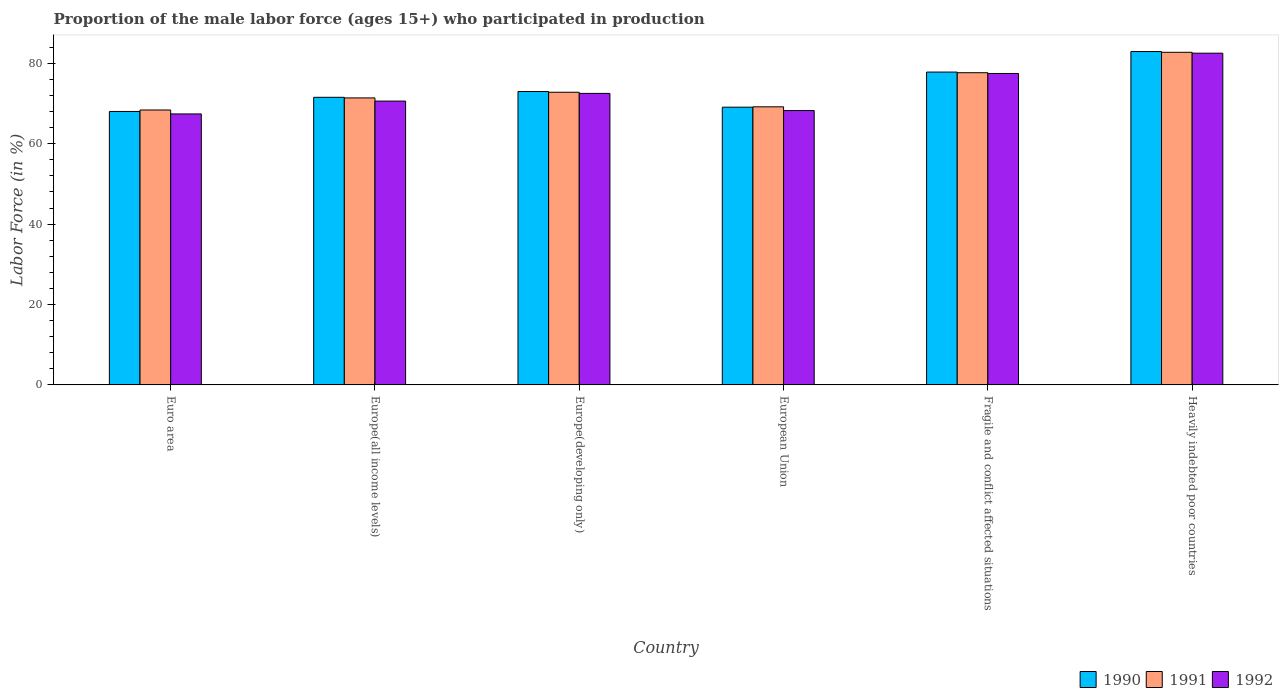How many different coloured bars are there?
Your answer should be compact. 3. How many groups of bars are there?
Ensure brevity in your answer.  6. How many bars are there on the 4th tick from the left?
Ensure brevity in your answer.  3. In how many cases, is the number of bars for a given country not equal to the number of legend labels?
Provide a succinct answer. 0. What is the proportion of the male labor force who participated in production in 1991 in Europe(all income levels)?
Give a very brief answer. 71.41. Across all countries, what is the maximum proportion of the male labor force who participated in production in 1990?
Give a very brief answer. 82.95. Across all countries, what is the minimum proportion of the male labor force who participated in production in 1990?
Provide a succinct answer. 68.04. In which country was the proportion of the male labor force who participated in production in 1990 maximum?
Ensure brevity in your answer.  Heavily indebted poor countries. In which country was the proportion of the male labor force who participated in production in 1992 minimum?
Your response must be concise. Euro area. What is the total proportion of the male labor force who participated in production in 1992 in the graph?
Provide a succinct answer. 438.87. What is the difference between the proportion of the male labor force who participated in production in 1992 in Europe(developing only) and that in Fragile and conflict affected situations?
Provide a short and direct response. -4.96. What is the difference between the proportion of the male labor force who participated in production in 1992 in Euro area and the proportion of the male labor force who participated in production in 1990 in Europe(all income levels)?
Your response must be concise. -4.14. What is the average proportion of the male labor force who participated in production in 1992 per country?
Provide a short and direct response. 73.14. What is the difference between the proportion of the male labor force who participated in production of/in 1991 and proportion of the male labor force who participated in production of/in 1992 in European Union?
Your response must be concise. 0.93. In how many countries, is the proportion of the male labor force who participated in production in 1992 greater than 52 %?
Ensure brevity in your answer.  6. What is the ratio of the proportion of the male labor force who participated in production in 1990 in Euro area to that in Europe(developing only)?
Keep it short and to the point. 0.93. Is the difference between the proportion of the male labor force who participated in production in 1991 in Europe(all income levels) and Fragile and conflict affected situations greater than the difference between the proportion of the male labor force who participated in production in 1992 in Europe(all income levels) and Fragile and conflict affected situations?
Your response must be concise. Yes. What is the difference between the highest and the second highest proportion of the male labor force who participated in production in 1992?
Make the answer very short. -10. What is the difference between the highest and the lowest proportion of the male labor force who participated in production in 1990?
Provide a succinct answer. 14.91. What does the 3rd bar from the left in Fragile and conflict affected situations represents?
Your answer should be very brief. 1992. Is it the case that in every country, the sum of the proportion of the male labor force who participated in production in 1990 and proportion of the male labor force who participated in production in 1992 is greater than the proportion of the male labor force who participated in production in 1991?
Give a very brief answer. Yes. How many bars are there?
Your answer should be very brief. 18. Are all the bars in the graph horizontal?
Give a very brief answer. No. How many countries are there in the graph?
Your response must be concise. 6. What is the difference between two consecutive major ticks on the Y-axis?
Make the answer very short. 20. Are the values on the major ticks of Y-axis written in scientific E-notation?
Offer a terse response. No. Does the graph contain grids?
Ensure brevity in your answer.  No. How are the legend labels stacked?
Keep it short and to the point. Horizontal. What is the title of the graph?
Provide a short and direct response. Proportion of the male labor force (ages 15+) who participated in production. Does "1984" appear as one of the legend labels in the graph?
Give a very brief answer. No. What is the label or title of the Y-axis?
Provide a succinct answer. Labor Force (in %). What is the Labor Force (in %) in 1990 in Euro area?
Offer a terse response. 68.04. What is the Labor Force (in %) of 1991 in Euro area?
Provide a short and direct response. 68.4. What is the Labor Force (in %) in 1992 in Euro area?
Your answer should be very brief. 67.42. What is the Labor Force (in %) in 1990 in Europe(all income levels)?
Make the answer very short. 71.56. What is the Labor Force (in %) in 1991 in Europe(all income levels)?
Give a very brief answer. 71.41. What is the Labor Force (in %) of 1992 in Europe(all income levels)?
Make the answer very short. 70.62. What is the Labor Force (in %) of 1990 in Europe(developing only)?
Offer a terse response. 73. What is the Labor Force (in %) in 1991 in Europe(developing only)?
Ensure brevity in your answer.  72.82. What is the Labor Force (in %) of 1992 in Europe(developing only)?
Your answer should be very brief. 72.53. What is the Labor Force (in %) in 1990 in European Union?
Make the answer very short. 69.1. What is the Labor Force (in %) of 1991 in European Union?
Offer a terse response. 69.19. What is the Labor Force (in %) of 1992 in European Union?
Ensure brevity in your answer.  68.26. What is the Labor Force (in %) in 1990 in Fragile and conflict affected situations?
Offer a terse response. 77.84. What is the Labor Force (in %) in 1991 in Fragile and conflict affected situations?
Offer a very short reply. 77.68. What is the Labor Force (in %) in 1992 in Fragile and conflict affected situations?
Make the answer very short. 77.49. What is the Labor Force (in %) of 1990 in Heavily indebted poor countries?
Your answer should be very brief. 82.95. What is the Labor Force (in %) in 1991 in Heavily indebted poor countries?
Offer a terse response. 82.76. What is the Labor Force (in %) of 1992 in Heavily indebted poor countries?
Your answer should be compact. 82.54. Across all countries, what is the maximum Labor Force (in %) of 1990?
Your response must be concise. 82.95. Across all countries, what is the maximum Labor Force (in %) of 1991?
Provide a short and direct response. 82.76. Across all countries, what is the maximum Labor Force (in %) of 1992?
Your answer should be compact. 82.54. Across all countries, what is the minimum Labor Force (in %) of 1990?
Provide a short and direct response. 68.04. Across all countries, what is the minimum Labor Force (in %) of 1991?
Your answer should be very brief. 68.4. Across all countries, what is the minimum Labor Force (in %) in 1992?
Ensure brevity in your answer.  67.42. What is the total Labor Force (in %) in 1990 in the graph?
Give a very brief answer. 442.49. What is the total Labor Force (in %) in 1991 in the graph?
Provide a succinct answer. 442.26. What is the total Labor Force (in %) in 1992 in the graph?
Offer a very short reply. 438.87. What is the difference between the Labor Force (in %) of 1990 in Euro area and that in Europe(all income levels)?
Your answer should be compact. -3.52. What is the difference between the Labor Force (in %) of 1991 in Euro area and that in Europe(all income levels)?
Offer a terse response. -3. What is the difference between the Labor Force (in %) in 1992 in Euro area and that in Europe(all income levels)?
Your response must be concise. -3.2. What is the difference between the Labor Force (in %) of 1990 in Euro area and that in Europe(developing only)?
Offer a very short reply. -4.96. What is the difference between the Labor Force (in %) in 1991 in Euro area and that in Europe(developing only)?
Provide a succinct answer. -4.41. What is the difference between the Labor Force (in %) in 1992 in Euro area and that in Europe(developing only)?
Provide a succinct answer. -5.11. What is the difference between the Labor Force (in %) of 1990 in Euro area and that in European Union?
Provide a short and direct response. -1.06. What is the difference between the Labor Force (in %) in 1991 in Euro area and that in European Union?
Provide a short and direct response. -0.79. What is the difference between the Labor Force (in %) of 1992 in Euro area and that in European Union?
Your response must be concise. -0.83. What is the difference between the Labor Force (in %) of 1990 in Euro area and that in Fragile and conflict affected situations?
Provide a short and direct response. -9.8. What is the difference between the Labor Force (in %) in 1991 in Euro area and that in Fragile and conflict affected situations?
Ensure brevity in your answer.  -9.27. What is the difference between the Labor Force (in %) of 1992 in Euro area and that in Fragile and conflict affected situations?
Ensure brevity in your answer.  -10.07. What is the difference between the Labor Force (in %) of 1990 in Euro area and that in Heavily indebted poor countries?
Offer a very short reply. -14.91. What is the difference between the Labor Force (in %) of 1991 in Euro area and that in Heavily indebted poor countries?
Provide a short and direct response. -14.35. What is the difference between the Labor Force (in %) in 1992 in Euro area and that in Heavily indebted poor countries?
Provide a short and direct response. -15.11. What is the difference between the Labor Force (in %) of 1990 in Europe(all income levels) and that in Europe(developing only)?
Keep it short and to the point. -1.44. What is the difference between the Labor Force (in %) in 1991 in Europe(all income levels) and that in Europe(developing only)?
Provide a succinct answer. -1.41. What is the difference between the Labor Force (in %) of 1992 in Europe(all income levels) and that in Europe(developing only)?
Provide a short and direct response. -1.91. What is the difference between the Labor Force (in %) of 1990 in Europe(all income levels) and that in European Union?
Provide a succinct answer. 2.46. What is the difference between the Labor Force (in %) of 1991 in Europe(all income levels) and that in European Union?
Offer a terse response. 2.22. What is the difference between the Labor Force (in %) of 1992 in Europe(all income levels) and that in European Union?
Keep it short and to the point. 2.36. What is the difference between the Labor Force (in %) in 1990 in Europe(all income levels) and that in Fragile and conflict affected situations?
Your answer should be very brief. -6.28. What is the difference between the Labor Force (in %) in 1991 in Europe(all income levels) and that in Fragile and conflict affected situations?
Your answer should be compact. -6.27. What is the difference between the Labor Force (in %) of 1992 in Europe(all income levels) and that in Fragile and conflict affected situations?
Offer a very short reply. -6.87. What is the difference between the Labor Force (in %) of 1990 in Europe(all income levels) and that in Heavily indebted poor countries?
Ensure brevity in your answer.  -11.39. What is the difference between the Labor Force (in %) in 1991 in Europe(all income levels) and that in Heavily indebted poor countries?
Your answer should be very brief. -11.35. What is the difference between the Labor Force (in %) of 1992 in Europe(all income levels) and that in Heavily indebted poor countries?
Your answer should be compact. -11.92. What is the difference between the Labor Force (in %) of 1990 in Europe(developing only) and that in European Union?
Offer a very short reply. 3.9. What is the difference between the Labor Force (in %) in 1991 in Europe(developing only) and that in European Union?
Make the answer very short. 3.62. What is the difference between the Labor Force (in %) of 1992 in Europe(developing only) and that in European Union?
Offer a very short reply. 4.28. What is the difference between the Labor Force (in %) of 1990 in Europe(developing only) and that in Fragile and conflict affected situations?
Your answer should be compact. -4.84. What is the difference between the Labor Force (in %) of 1991 in Europe(developing only) and that in Fragile and conflict affected situations?
Provide a short and direct response. -4.86. What is the difference between the Labor Force (in %) in 1992 in Europe(developing only) and that in Fragile and conflict affected situations?
Provide a succinct answer. -4.96. What is the difference between the Labor Force (in %) of 1990 in Europe(developing only) and that in Heavily indebted poor countries?
Your answer should be compact. -9.95. What is the difference between the Labor Force (in %) of 1991 in Europe(developing only) and that in Heavily indebted poor countries?
Provide a short and direct response. -9.94. What is the difference between the Labor Force (in %) of 1992 in Europe(developing only) and that in Heavily indebted poor countries?
Keep it short and to the point. -10. What is the difference between the Labor Force (in %) of 1990 in European Union and that in Fragile and conflict affected situations?
Offer a very short reply. -8.73. What is the difference between the Labor Force (in %) of 1991 in European Union and that in Fragile and conflict affected situations?
Your answer should be very brief. -8.49. What is the difference between the Labor Force (in %) of 1992 in European Union and that in Fragile and conflict affected situations?
Ensure brevity in your answer.  -9.23. What is the difference between the Labor Force (in %) in 1990 in European Union and that in Heavily indebted poor countries?
Ensure brevity in your answer.  -13.84. What is the difference between the Labor Force (in %) in 1991 in European Union and that in Heavily indebted poor countries?
Your answer should be compact. -13.56. What is the difference between the Labor Force (in %) of 1992 in European Union and that in Heavily indebted poor countries?
Offer a very short reply. -14.28. What is the difference between the Labor Force (in %) of 1990 in Fragile and conflict affected situations and that in Heavily indebted poor countries?
Keep it short and to the point. -5.11. What is the difference between the Labor Force (in %) in 1991 in Fragile and conflict affected situations and that in Heavily indebted poor countries?
Provide a succinct answer. -5.08. What is the difference between the Labor Force (in %) of 1992 in Fragile and conflict affected situations and that in Heavily indebted poor countries?
Offer a very short reply. -5.05. What is the difference between the Labor Force (in %) in 1990 in Euro area and the Labor Force (in %) in 1991 in Europe(all income levels)?
Your response must be concise. -3.37. What is the difference between the Labor Force (in %) of 1990 in Euro area and the Labor Force (in %) of 1992 in Europe(all income levels)?
Offer a terse response. -2.58. What is the difference between the Labor Force (in %) of 1991 in Euro area and the Labor Force (in %) of 1992 in Europe(all income levels)?
Provide a short and direct response. -2.22. What is the difference between the Labor Force (in %) of 1990 in Euro area and the Labor Force (in %) of 1991 in Europe(developing only)?
Offer a very short reply. -4.78. What is the difference between the Labor Force (in %) of 1990 in Euro area and the Labor Force (in %) of 1992 in Europe(developing only)?
Your response must be concise. -4.49. What is the difference between the Labor Force (in %) in 1991 in Euro area and the Labor Force (in %) in 1992 in Europe(developing only)?
Give a very brief answer. -4.13. What is the difference between the Labor Force (in %) of 1990 in Euro area and the Labor Force (in %) of 1991 in European Union?
Provide a succinct answer. -1.15. What is the difference between the Labor Force (in %) of 1990 in Euro area and the Labor Force (in %) of 1992 in European Union?
Offer a very short reply. -0.22. What is the difference between the Labor Force (in %) in 1991 in Euro area and the Labor Force (in %) in 1992 in European Union?
Keep it short and to the point. 0.15. What is the difference between the Labor Force (in %) in 1990 in Euro area and the Labor Force (in %) in 1991 in Fragile and conflict affected situations?
Provide a succinct answer. -9.64. What is the difference between the Labor Force (in %) in 1990 in Euro area and the Labor Force (in %) in 1992 in Fragile and conflict affected situations?
Offer a terse response. -9.45. What is the difference between the Labor Force (in %) of 1991 in Euro area and the Labor Force (in %) of 1992 in Fragile and conflict affected situations?
Your answer should be compact. -9.09. What is the difference between the Labor Force (in %) of 1990 in Euro area and the Labor Force (in %) of 1991 in Heavily indebted poor countries?
Provide a succinct answer. -14.72. What is the difference between the Labor Force (in %) in 1990 in Euro area and the Labor Force (in %) in 1992 in Heavily indebted poor countries?
Make the answer very short. -14.5. What is the difference between the Labor Force (in %) in 1991 in Euro area and the Labor Force (in %) in 1992 in Heavily indebted poor countries?
Your answer should be compact. -14.13. What is the difference between the Labor Force (in %) in 1990 in Europe(all income levels) and the Labor Force (in %) in 1991 in Europe(developing only)?
Offer a very short reply. -1.26. What is the difference between the Labor Force (in %) of 1990 in Europe(all income levels) and the Labor Force (in %) of 1992 in Europe(developing only)?
Your response must be concise. -0.97. What is the difference between the Labor Force (in %) of 1991 in Europe(all income levels) and the Labor Force (in %) of 1992 in Europe(developing only)?
Provide a succinct answer. -1.12. What is the difference between the Labor Force (in %) in 1990 in Europe(all income levels) and the Labor Force (in %) in 1991 in European Union?
Ensure brevity in your answer.  2.37. What is the difference between the Labor Force (in %) in 1990 in Europe(all income levels) and the Labor Force (in %) in 1992 in European Union?
Ensure brevity in your answer.  3.3. What is the difference between the Labor Force (in %) of 1991 in Europe(all income levels) and the Labor Force (in %) of 1992 in European Union?
Your response must be concise. 3.15. What is the difference between the Labor Force (in %) in 1990 in Europe(all income levels) and the Labor Force (in %) in 1991 in Fragile and conflict affected situations?
Make the answer very short. -6.12. What is the difference between the Labor Force (in %) of 1990 in Europe(all income levels) and the Labor Force (in %) of 1992 in Fragile and conflict affected situations?
Offer a very short reply. -5.93. What is the difference between the Labor Force (in %) of 1991 in Europe(all income levels) and the Labor Force (in %) of 1992 in Fragile and conflict affected situations?
Your answer should be compact. -6.08. What is the difference between the Labor Force (in %) of 1990 in Europe(all income levels) and the Labor Force (in %) of 1991 in Heavily indebted poor countries?
Your answer should be very brief. -11.2. What is the difference between the Labor Force (in %) of 1990 in Europe(all income levels) and the Labor Force (in %) of 1992 in Heavily indebted poor countries?
Keep it short and to the point. -10.98. What is the difference between the Labor Force (in %) in 1991 in Europe(all income levels) and the Labor Force (in %) in 1992 in Heavily indebted poor countries?
Offer a terse response. -11.13. What is the difference between the Labor Force (in %) in 1990 in Europe(developing only) and the Labor Force (in %) in 1991 in European Union?
Make the answer very short. 3.81. What is the difference between the Labor Force (in %) of 1990 in Europe(developing only) and the Labor Force (in %) of 1992 in European Union?
Make the answer very short. 4.74. What is the difference between the Labor Force (in %) in 1991 in Europe(developing only) and the Labor Force (in %) in 1992 in European Union?
Provide a succinct answer. 4.56. What is the difference between the Labor Force (in %) in 1990 in Europe(developing only) and the Labor Force (in %) in 1991 in Fragile and conflict affected situations?
Your response must be concise. -4.68. What is the difference between the Labor Force (in %) in 1990 in Europe(developing only) and the Labor Force (in %) in 1992 in Fragile and conflict affected situations?
Ensure brevity in your answer.  -4.49. What is the difference between the Labor Force (in %) in 1991 in Europe(developing only) and the Labor Force (in %) in 1992 in Fragile and conflict affected situations?
Keep it short and to the point. -4.68. What is the difference between the Labor Force (in %) in 1990 in Europe(developing only) and the Labor Force (in %) in 1991 in Heavily indebted poor countries?
Your answer should be very brief. -9.76. What is the difference between the Labor Force (in %) in 1990 in Europe(developing only) and the Labor Force (in %) in 1992 in Heavily indebted poor countries?
Your answer should be compact. -9.54. What is the difference between the Labor Force (in %) of 1991 in Europe(developing only) and the Labor Force (in %) of 1992 in Heavily indebted poor countries?
Provide a short and direct response. -9.72. What is the difference between the Labor Force (in %) in 1990 in European Union and the Labor Force (in %) in 1991 in Fragile and conflict affected situations?
Your answer should be very brief. -8.58. What is the difference between the Labor Force (in %) of 1990 in European Union and the Labor Force (in %) of 1992 in Fragile and conflict affected situations?
Ensure brevity in your answer.  -8.39. What is the difference between the Labor Force (in %) in 1991 in European Union and the Labor Force (in %) in 1992 in Fragile and conflict affected situations?
Offer a terse response. -8.3. What is the difference between the Labor Force (in %) of 1990 in European Union and the Labor Force (in %) of 1991 in Heavily indebted poor countries?
Your answer should be compact. -13.65. What is the difference between the Labor Force (in %) of 1990 in European Union and the Labor Force (in %) of 1992 in Heavily indebted poor countries?
Your answer should be very brief. -13.43. What is the difference between the Labor Force (in %) of 1991 in European Union and the Labor Force (in %) of 1992 in Heavily indebted poor countries?
Ensure brevity in your answer.  -13.34. What is the difference between the Labor Force (in %) in 1990 in Fragile and conflict affected situations and the Labor Force (in %) in 1991 in Heavily indebted poor countries?
Keep it short and to the point. -4.92. What is the difference between the Labor Force (in %) in 1990 in Fragile and conflict affected situations and the Labor Force (in %) in 1992 in Heavily indebted poor countries?
Provide a succinct answer. -4.7. What is the difference between the Labor Force (in %) in 1991 in Fragile and conflict affected situations and the Labor Force (in %) in 1992 in Heavily indebted poor countries?
Keep it short and to the point. -4.86. What is the average Labor Force (in %) in 1990 per country?
Provide a short and direct response. 73.75. What is the average Labor Force (in %) in 1991 per country?
Make the answer very short. 73.71. What is the average Labor Force (in %) in 1992 per country?
Give a very brief answer. 73.14. What is the difference between the Labor Force (in %) in 1990 and Labor Force (in %) in 1991 in Euro area?
Make the answer very short. -0.36. What is the difference between the Labor Force (in %) of 1990 and Labor Force (in %) of 1992 in Euro area?
Offer a very short reply. 0.62. What is the difference between the Labor Force (in %) of 1991 and Labor Force (in %) of 1992 in Euro area?
Your response must be concise. 0.98. What is the difference between the Labor Force (in %) in 1990 and Labor Force (in %) in 1991 in Europe(all income levels)?
Make the answer very short. 0.15. What is the difference between the Labor Force (in %) of 1990 and Labor Force (in %) of 1992 in Europe(all income levels)?
Your answer should be compact. 0.94. What is the difference between the Labor Force (in %) of 1991 and Labor Force (in %) of 1992 in Europe(all income levels)?
Provide a short and direct response. 0.79. What is the difference between the Labor Force (in %) of 1990 and Labor Force (in %) of 1991 in Europe(developing only)?
Make the answer very short. 0.18. What is the difference between the Labor Force (in %) of 1990 and Labor Force (in %) of 1992 in Europe(developing only)?
Your answer should be very brief. 0.47. What is the difference between the Labor Force (in %) in 1991 and Labor Force (in %) in 1992 in Europe(developing only)?
Ensure brevity in your answer.  0.28. What is the difference between the Labor Force (in %) of 1990 and Labor Force (in %) of 1991 in European Union?
Provide a short and direct response. -0.09. What is the difference between the Labor Force (in %) in 1990 and Labor Force (in %) in 1992 in European Union?
Provide a succinct answer. 0.85. What is the difference between the Labor Force (in %) of 1991 and Labor Force (in %) of 1992 in European Union?
Your response must be concise. 0.93. What is the difference between the Labor Force (in %) of 1990 and Labor Force (in %) of 1991 in Fragile and conflict affected situations?
Make the answer very short. 0.16. What is the difference between the Labor Force (in %) of 1990 and Labor Force (in %) of 1992 in Fragile and conflict affected situations?
Offer a very short reply. 0.35. What is the difference between the Labor Force (in %) of 1991 and Labor Force (in %) of 1992 in Fragile and conflict affected situations?
Offer a very short reply. 0.19. What is the difference between the Labor Force (in %) of 1990 and Labor Force (in %) of 1991 in Heavily indebted poor countries?
Your answer should be compact. 0.19. What is the difference between the Labor Force (in %) in 1990 and Labor Force (in %) in 1992 in Heavily indebted poor countries?
Your response must be concise. 0.41. What is the difference between the Labor Force (in %) of 1991 and Labor Force (in %) of 1992 in Heavily indebted poor countries?
Offer a terse response. 0.22. What is the ratio of the Labor Force (in %) in 1990 in Euro area to that in Europe(all income levels)?
Give a very brief answer. 0.95. What is the ratio of the Labor Force (in %) of 1991 in Euro area to that in Europe(all income levels)?
Keep it short and to the point. 0.96. What is the ratio of the Labor Force (in %) of 1992 in Euro area to that in Europe(all income levels)?
Offer a terse response. 0.95. What is the ratio of the Labor Force (in %) of 1990 in Euro area to that in Europe(developing only)?
Make the answer very short. 0.93. What is the ratio of the Labor Force (in %) in 1991 in Euro area to that in Europe(developing only)?
Offer a very short reply. 0.94. What is the ratio of the Labor Force (in %) of 1992 in Euro area to that in Europe(developing only)?
Your answer should be compact. 0.93. What is the ratio of the Labor Force (in %) in 1990 in Euro area to that in European Union?
Provide a succinct answer. 0.98. What is the ratio of the Labor Force (in %) of 1991 in Euro area to that in European Union?
Offer a terse response. 0.99. What is the ratio of the Labor Force (in %) in 1992 in Euro area to that in European Union?
Your response must be concise. 0.99. What is the ratio of the Labor Force (in %) of 1990 in Euro area to that in Fragile and conflict affected situations?
Keep it short and to the point. 0.87. What is the ratio of the Labor Force (in %) in 1991 in Euro area to that in Fragile and conflict affected situations?
Ensure brevity in your answer.  0.88. What is the ratio of the Labor Force (in %) of 1992 in Euro area to that in Fragile and conflict affected situations?
Make the answer very short. 0.87. What is the ratio of the Labor Force (in %) in 1990 in Euro area to that in Heavily indebted poor countries?
Give a very brief answer. 0.82. What is the ratio of the Labor Force (in %) of 1991 in Euro area to that in Heavily indebted poor countries?
Your answer should be compact. 0.83. What is the ratio of the Labor Force (in %) of 1992 in Euro area to that in Heavily indebted poor countries?
Offer a very short reply. 0.82. What is the ratio of the Labor Force (in %) in 1990 in Europe(all income levels) to that in Europe(developing only)?
Give a very brief answer. 0.98. What is the ratio of the Labor Force (in %) in 1991 in Europe(all income levels) to that in Europe(developing only)?
Offer a very short reply. 0.98. What is the ratio of the Labor Force (in %) of 1992 in Europe(all income levels) to that in Europe(developing only)?
Keep it short and to the point. 0.97. What is the ratio of the Labor Force (in %) of 1990 in Europe(all income levels) to that in European Union?
Your answer should be very brief. 1.04. What is the ratio of the Labor Force (in %) of 1991 in Europe(all income levels) to that in European Union?
Offer a very short reply. 1.03. What is the ratio of the Labor Force (in %) in 1992 in Europe(all income levels) to that in European Union?
Offer a terse response. 1.03. What is the ratio of the Labor Force (in %) in 1990 in Europe(all income levels) to that in Fragile and conflict affected situations?
Offer a very short reply. 0.92. What is the ratio of the Labor Force (in %) in 1991 in Europe(all income levels) to that in Fragile and conflict affected situations?
Offer a very short reply. 0.92. What is the ratio of the Labor Force (in %) of 1992 in Europe(all income levels) to that in Fragile and conflict affected situations?
Offer a terse response. 0.91. What is the ratio of the Labor Force (in %) in 1990 in Europe(all income levels) to that in Heavily indebted poor countries?
Your response must be concise. 0.86. What is the ratio of the Labor Force (in %) of 1991 in Europe(all income levels) to that in Heavily indebted poor countries?
Your response must be concise. 0.86. What is the ratio of the Labor Force (in %) in 1992 in Europe(all income levels) to that in Heavily indebted poor countries?
Give a very brief answer. 0.86. What is the ratio of the Labor Force (in %) of 1990 in Europe(developing only) to that in European Union?
Make the answer very short. 1.06. What is the ratio of the Labor Force (in %) of 1991 in Europe(developing only) to that in European Union?
Your response must be concise. 1.05. What is the ratio of the Labor Force (in %) of 1992 in Europe(developing only) to that in European Union?
Make the answer very short. 1.06. What is the ratio of the Labor Force (in %) of 1990 in Europe(developing only) to that in Fragile and conflict affected situations?
Your response must be concise. 0.94. What is the ratio of the Labor Force (in %) of 1991 in Europe(developing only) to that in Fragile and conflict affected situations?
Offer a very short reply. 0.94. What is the ratio of the Labor Force (in %) of 1992 in Europe(developing only) to that in Fragile and conflict affected situations?
Give a very brief answer. 0.94. What is the ratio of the Labor Force (in %) in 1990 in Europe(developing only) to that in Heavily indebted poor countries?
Provide a succinct answer. 0.88. What is the ratio of the Labor Force (in %) in 1991 in Europe(developing only) to that in Heavily indebted poor countries?
Your response must be concise. 0.88. What is the ratio of the Labor Force (in %) in 1992 in Europe(developing only) to that in Heavily indebted poor countries?
Your answer should be compact. 0.88. What is the ratio of the Labor Force (in %) in 1990 in European Union to that in Fragile and conflict affected situations?
Offer a terse response. 0.89. What is the ratio of the Labor Force (in %) in 1991 in European Union to that in Fragile and conflict affected situations?
Your response must be concise. 0.89. What is the ratio of the Labor Force (in %) of 1992 in European Union to that in Fragile and conflict affected situations?
Offer a terse response. 0.88. What is the ratio of the Labor Force (in %) in 1990 in European Union to that in Heavily indebted poor countries?
Give a very brief answer. 0.83. What is the ratio of the Labor Force (in %) in 1991 in European Union to that in Heavily indebted poor countries?
Your answer should be very brief. 0.84. What is the ratio of the Labor Force (in %) in 1992 in European Union to that in Heavily indebted poor countries?
Ensure brevity in your answer.  0.83. What is the ratio of the Labor Force (in %) of 1990 in Fragile and conflict affected situations to that in Heavily indebted poor countries?
Keep it short and to the point. 0.94. What is the ratio of the Labor Force (in %) in 1991 in Fragile and conflict affected situations to that in Heavily indebted poor countries?
Give a very brief answer. 0.94. What is the ratio of the Labor Force (in %) of 1992 in Fragile and conflict affected situations to that in Heavily indebted poor countries?
Offer a terse response. 0.94. What is the difference between the highest and the second highest Labor Force (in %) of 1990?
Provide a short and direct response. 5.11. What is the difference between the highest and the second highest Labor Force (in %) of 1991?
Offer a very short reply. 5.08. What is the difference between the highest and the second highest Labor Force (in %) of 1992?
Offer a terse response. 5.05. What is the difference between the highest and the lowest Labor Force (in %) in 1990?
Your response must be concise. 14.91. What is the difference between the highest and the lowest Labor Force (in %) of 1991?
Ensure brevity in your answer.  14.35. What is the difference between the highest and the lowest Labor Force (in %) of 1992?
Your answer should be very brief. 15.11. 